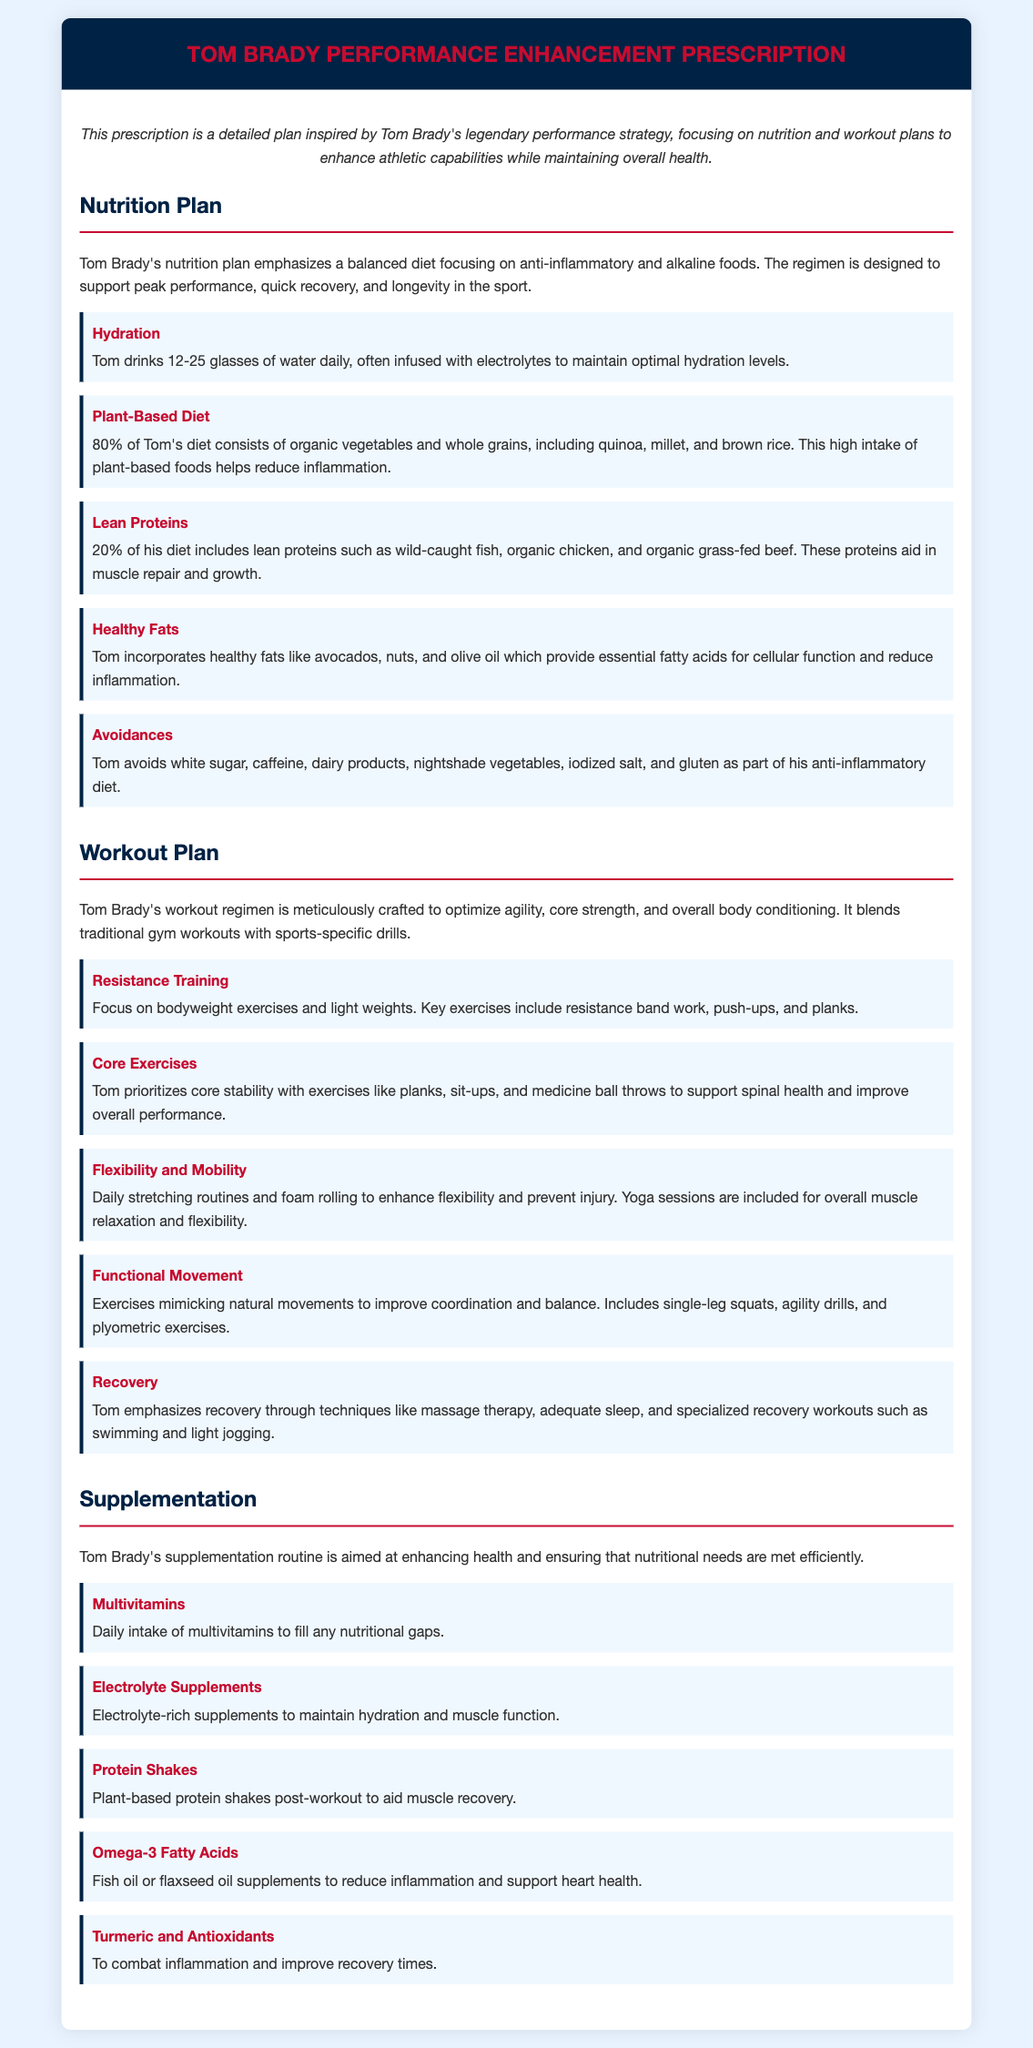What is Tom Brady's hydration goal? Tom drinks 12-25 glasses of water daily, often infused with electrolytes to maintain optimal hydration levels.
Answer: 12-25 glasses What percentage of Tom's diet consists of plant-based foods? 80% of Tom's diet consists of organic vegetables and whole grains, indicating a focus on plant-based foods.
Answer: 80% Which lean proteins does Tom include in his diet? Tom includes wild-caught fish, organic chicken, and organic grass-fed beef as part of his lean protein intake.
Answer: Wild-caught fish, organic chicken, organic grass-fed beef What type of training does Tom prioritize for core stability? Exercises like planks, sit-ups, and medicine ball throws are prioritized to support spinal health and improve performance.
Answer: Planks, sit-ups, medicine ball throws What supplementation does Tom take for inflammation reduction? Turmeric and antioxidants are used to combat inflammation and improve recovery times.
Answer: Turmeric and antioxidants How much emphasis does Tom put on recovery? Through techniques like massage therapy, adequate sleep, and specialized recovery workouts, Tom emphasizes recovery significantly.
Answer: Significant emphasis What is the primary focus of Tom’s workout regimen? The workout regimen is meticulously crafted to optimize agility, core strength, and overall body conditioning.
Answer: Agility, core strength, body conditioning What kind of diet does Tom Brady avoid? Tom avoids white sugar, caffeine, dairy products, nightshade vegetables, iodized salt, and gluten for anti-inflammatory reasons.
Answer: White sugar, caffeine, dairy, nightshade vegetables, iodized salt, gluten 